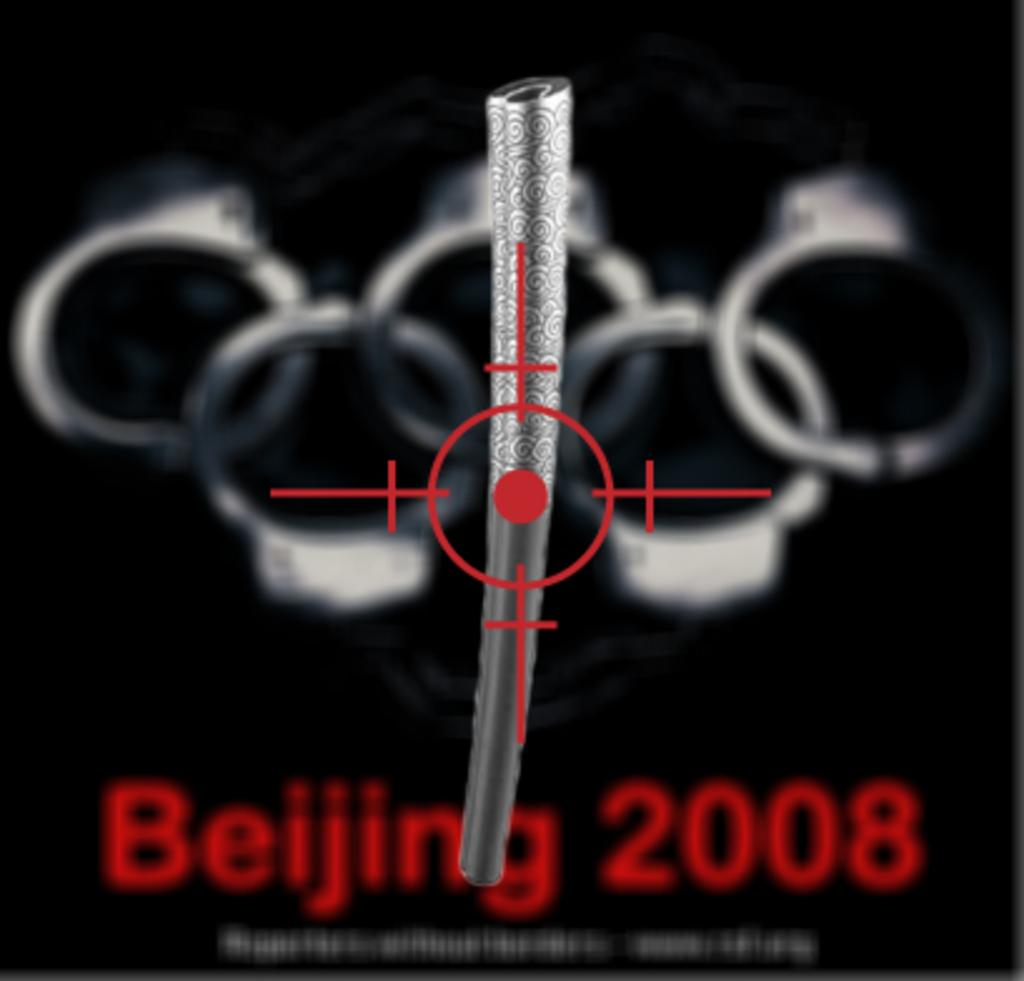<image>
Give a short and clear explanation of the subsequent image. A political poster shows a target on the bejing 2008 olympic rings which are depicted as handcuffs 